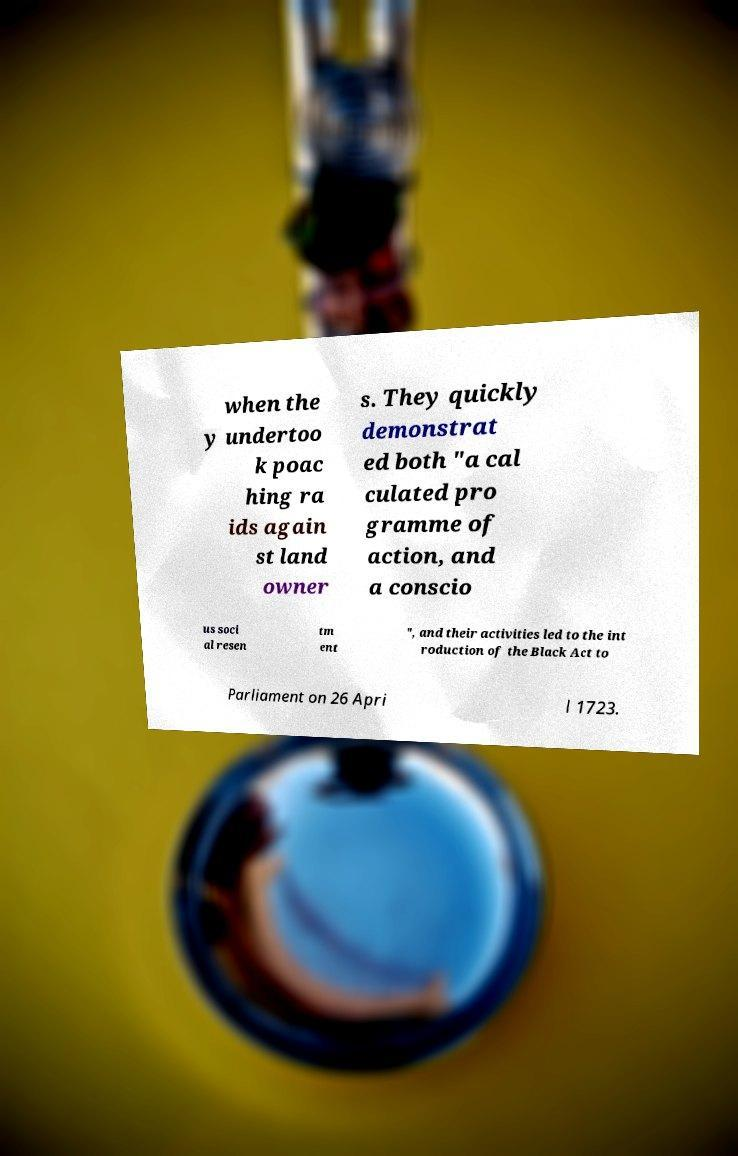For documentation purposes, I need the text within this image transcribed. Could you provide that? when the y undertoo k poac hing ra ids again st land owner s. They quickly demonstrat ed both "a cal culated pro gramme of action, and a conscio us soci al resen tm ent ", and their activities led to the int roduction of the Black Act to Parliament on 26 Apri l 1723. 